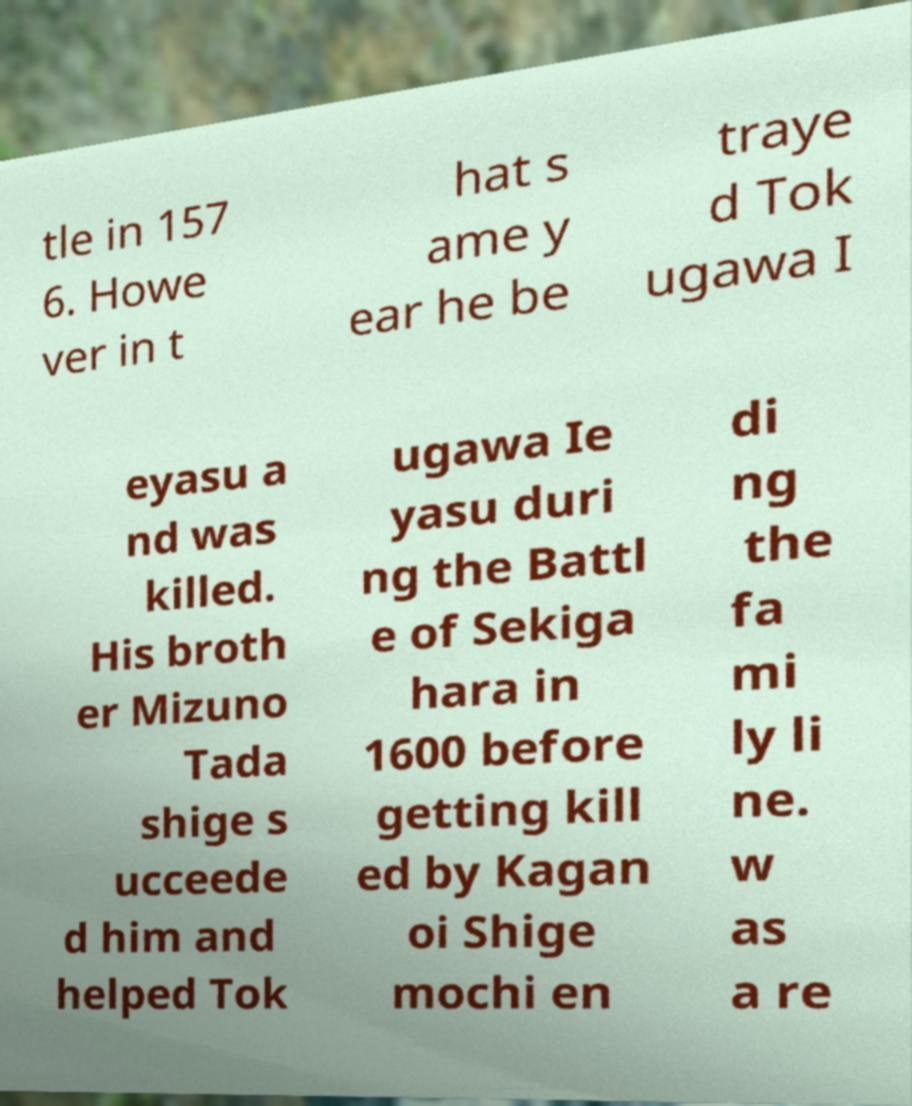Can you read and provide the text displayed in the image?This photo seems to have some interesting text. Can you extract and type it out for me? tle in 157 6. Howe ver in t hat s ame y ear he be traye d Tok ugawa I eyasu a nd was killed. His broth er Mizuno Tada shige s ucceede d him and helped Tok ugawa Ie yasu duri ng the Battl e of Sekiga hara in 1600 before getting kill ed by Kagan oi Shige mochi en di ng the fa mi ly li ne. w as a re 